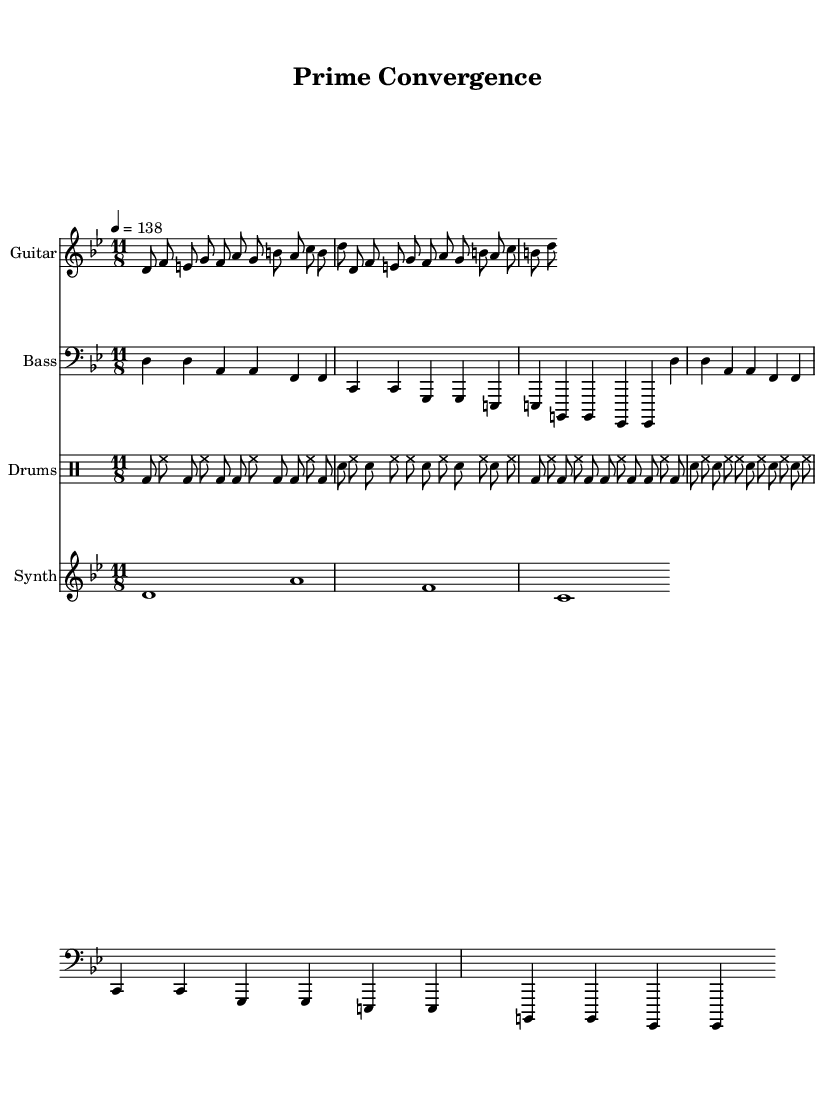What is the time signature of this music? The time signature is indicated at the beginning of the piece and can be seen above the staff. It is labeled as 11/8, which means there are 11 eighth note beats in each measure.
Answer: 11/8 What is the key signature of this music? The key signature is determined by the accidentals at the beginning of the staff. Here, there are two sharps indicated, which corresponds to the key of D minor or F# major, but given the use of the Phrygian mode, it aligns with D Phrygian.
Answer: D Phrygian What is the tempo marking of this music? The tempo marking is shown at the start of the score. It reads "4 = 138," meaning that the quarter note is set to a speed of 138 beats per minute.
Answer: 138 Identify the instrument associated with the "bassLine". The "bassLine" is placed under the instrument labeled "Bass," which typically refers to a lower-pitched instrument providing harmony and rhythm.
Answer: Bass How many measures are repeated in the guitar riff? The guitar riff section is marked with the instruction "repeat unfold 2," indicating that the previous section is repeated twice for a total of two measures.
Answer: 2 What kinds of rhythms can be found in the drum pattern? The drum pattern shows both bass drum (bd) and snare drum (sn) hits with a mixture of eighth notes and sixteenth notes, reflecting the complexity typical of progressive metal fusion.
Answer: Eighth and sixteenth 